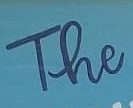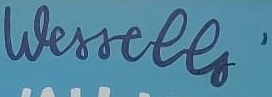Identify the words shown in these images in order, separated by a semicolon. The; Wessells' 